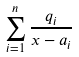<formula> <loc_0><loc_0><loc_500><loc_500>\sum _ { i = 1 } ^ { n } \frac { q _ { i } } { x - a _ { i } }</formula> 